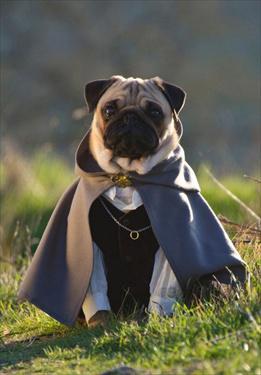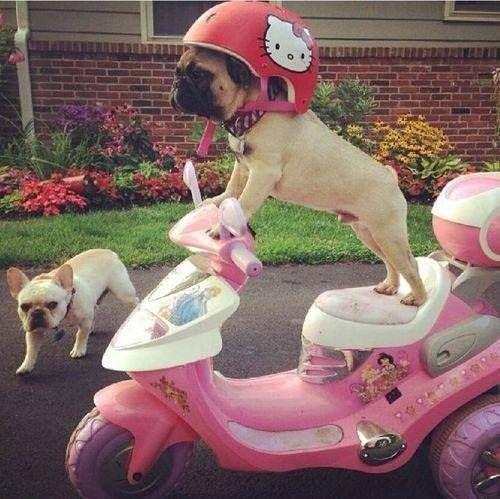The first image is the image on the left, the second image is the image on the right. Analyze the images presented: Is the assertion "In one of the images, you will find only one dog." valid? Answer yes or no. Yes. The first image is the image on the left, the second image is the image on the right. Examine the images to the left and right. Is the description "There are exactly six tan and black nosed pugs along side two predominately black dogs." accurate? Answer yes or no. No. 